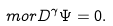Convert formula to latex. <formula><loc_0><loc_0><loc_500><loc_500>\ m o r { D } ^ { \gamma } \Psi = 0 .</formula> 